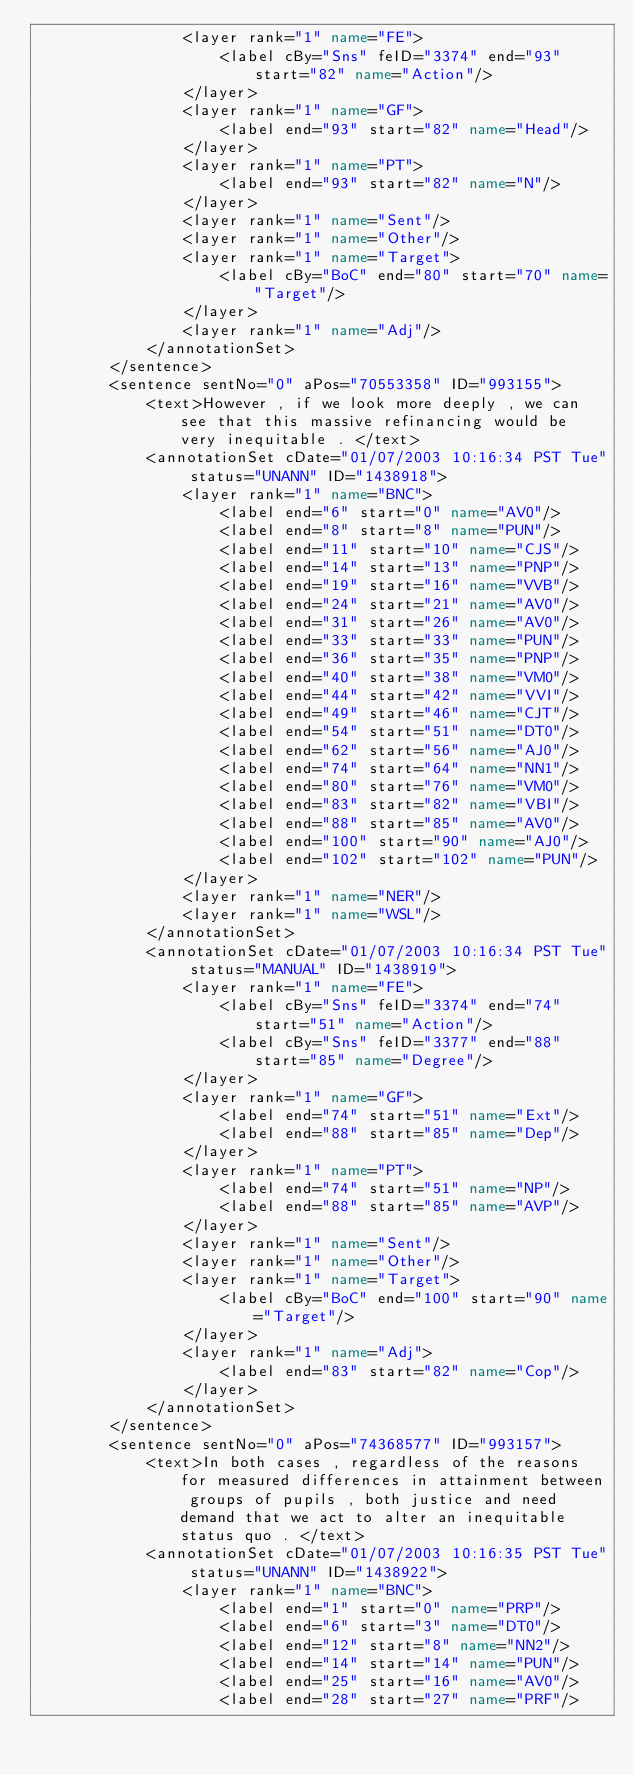<code> <loc_0><loc_0><loc_500><loc_500><_XML_>                <layer rank="1" name="FE">
                    <label cBy="Sns" feID="3374" end="93" start="82" name="Action"/>
                </layer>
                <layer rank="1" name="GF">
                    <label end="93" start="82" name="Head"/>
                </layer>
                <layer rank="1" name="PT">
                    <label end="93" start="82" name="N"/>
                </layer>
                <layer rank="1" name="Sent"/>
                <layer rank="1" name="Other"/>
                <layer rank="1" name="Target">
                    <label cBy="BoC" end="80" start="70" name="Target"/>
                </layer>
                <layer rank="1" name="Adj"/>
            </annotationSet>
        </sentence>
        <sentence sentNo="0" aPos="70553358" ID="993155">
            <text>However , if we look more deeply , we can see that this massive refinancing would be very inequitable . </text>
            <annotationSet cDate="01/07/2003 10:16:34 PST Tue" status="UNANN" ID="1438918">
                <layer rank="1" name="BNC">
                    <label end="6" start="0" name="AV0"/>
                    <label end="8" start="8" name="PUN"/>
                    <label end="11" start="10" name="CJS"/>
                    <label end="14" start="13" name="PNP"/>
                    <label end="19" start="16" name="VVB"/>
                    <label end="24" start="21" name="AV0"/>
                    <label end="31" start="26" name="AV0"/>
                    <label end="33" start="33" name="PUN"/>
                    <label end="36" start="35" name="PNP"/>
                    <label end="40" start="38" name="VM0"/>
                    <label end="44" start="42" name="VVI"/>
                    <label end="49" start="46" name="CJT"/>
                    <label end="54" start="51" name="DT0"/>
                    <label end="62" start="56" name="AJ0"/>
                    <label end="74" start="64" name="NN1"/>
                    <label end="80" start="76" name="VM0"/>
                    <label end="83" start="82" name="VBI"/>
                    <label end="88" start="85" name="AV0"/>
                    <label end="100" start="90" name="AJ0"/>
                    <label end="102" start="102" name="PUN"/>
                </layer>
                <layer rank="1" name="NER"/>
                <layer rank="1" name="WSL"/>
            </annotationSet>
            <annotationSet cDate="01/07/2003 10:16:34 PST Tue" status="MANUAL" ID="1438919">
                <layer rank="1" name="FE">
                    <label cBy="Sns" feID="3374" end="74" start="51" name="Action"/>
                    <label cBy="Sns" feID="3377" end="88" start="85" name="Degree"/>
                </layer>
                <layer rank="1" name="GF">
                    <label end="74" start="51" name="Ext"/>
                    <label end="88" start="85" name="Dep"/>
                </layer>
                <layer rank="1" name="PT">
                    <label end="74" start="51" name="NP"/>
                    <label end="88" start="85" name="AVP"/>
                </layer>
                <layer rank="1" name="Sent"/>
                <layer rank="1" name="Other"/>
                <layer rank="1" name="Target">
                    <label cBy="BoC" end="100" start="90" name="Target"/>
                </layer>
                <layer rank="1" name="Adj">
                    <label end="83" start="82" name="Cop"/>
                </layer>
            </annotationSet>
        </sentence>
        <sentence sentNo="0" aPos="74368577" ID="993157">
            <text>In both cases , regardless of the reasons for measured differences in attainment between groups of pupils , both justice and need demand that we act to alter an inequitable status quo . </text>
            <annotationSet cDate="01/07/2003 10:16:35 PST Tue" status="UNANN" ID="1438922">
                <layer rank="1" name="BNC">
                    <label end="1" start="0" name="PRP"/>
                    <label end="6" start="3" name="DT0"/>
                    <label end="12" start="8" name="NN2"/>
                    <label end="14" start="14" name="PUN"/>
                    <label end="25" start="16" name="AV0"/>
                    <label end="28" start="27" name="PRF"/></code> 